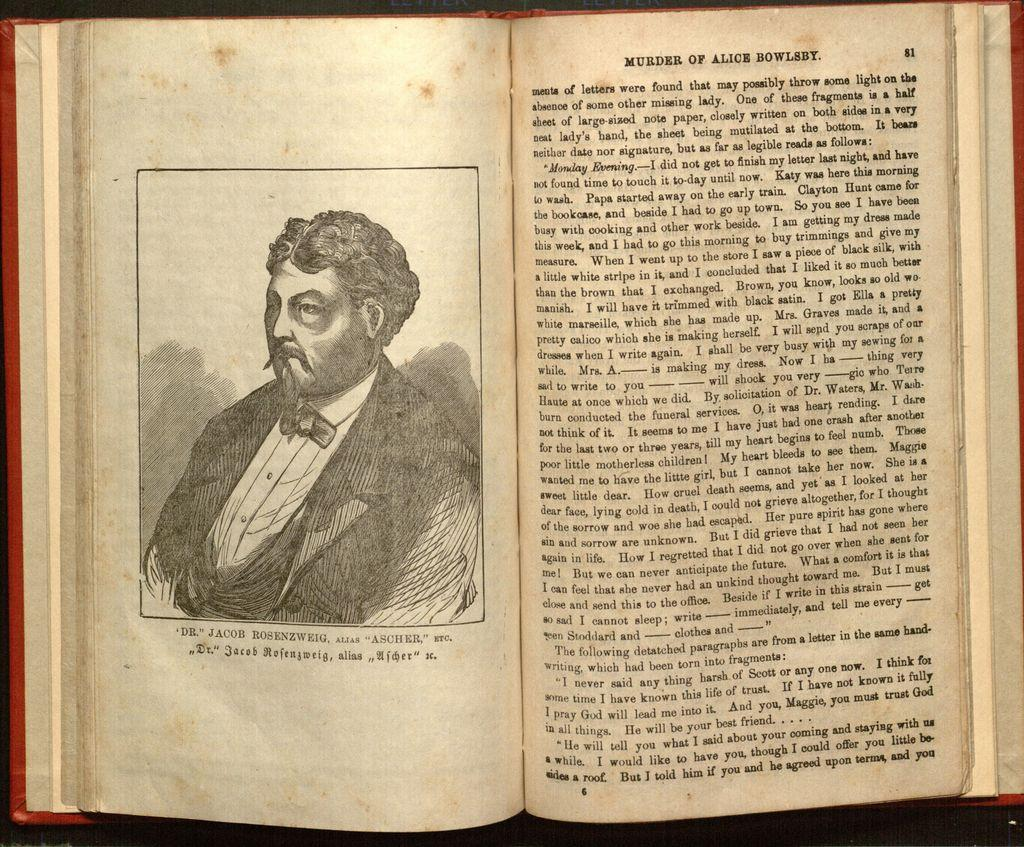<image>
Summarize the visual content of the image. A vintage book titled Murder of Alice Bowles opened to a middle page spread 